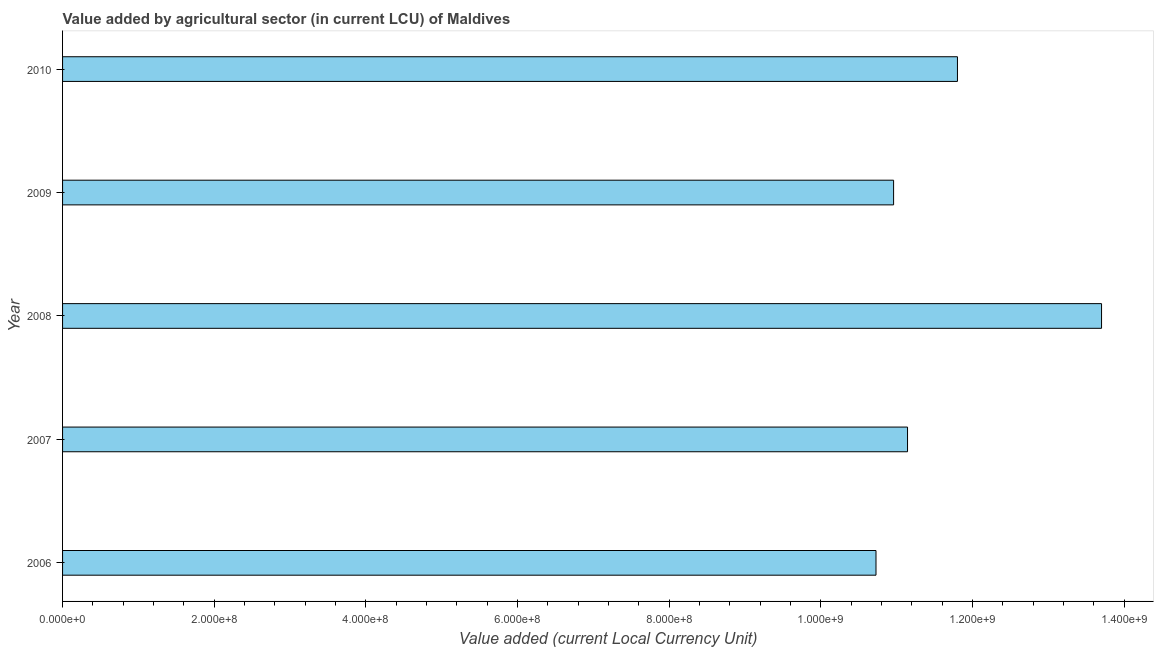Does the graph contain any zero values?
Your answer should be compact. No. What is the title of the graph?
Keep it short and to the point. Value added by agricultural sector (in current LCU) of Maldives. What is the label or title of the X-axis?
Make the answer very short. Value added (current Local Currency Unit). What is the value added by agriculture sector in 2006?
Make the answer very short. 1.07e+09. Across all years, what is the maximum value added by agriculture sector?
Provide a succinct answer. 1.37e+09. Across all years, what is the minimum value added by agriculture sector?
Offer a terse response. 1.07e+09. In which year was the value added by agriculture sector minimum?
Ensure brevity in your answer.  2006. What is the sum of the value added by agriculture sector?
Your response must be concise. 5.83e+09. What is the difference between the value added by agriculture sector in 2007 and 2009?
Make the answer very short. 1.84e+07. What is the average value added by agriculture sector per year?
Make the answer very short. 1.17e+09. What is the median value added by agriculture sector?
Offer a very short reply. 1.11e+09. Do a majority of the years between 2008 and 2007 (inclusive) have value added by agriculture sector greater than 800000000 LCU?
Offer a terse response. No. Is the value added by agriculture sector in 2009 less than that in 2010?
Ensure brevity in your answer.  Yes. Is the difference between the value added by agriculture sector in 2009 and 2010 greater than the difference between any two years?
Provide a short and direct response. No. What is the difference between the highest and the second highest value added by agriculture sector?
Your answer should be compact. 1.90e+08. Is the sum of the value added by agriculture sector in 2008 and 2010 greater than the maximum value added by agriculture sector across all years?
Offer a very short reply. Yes. What is the difference between the highest and the lowest value added by agriculture sector?
Give a very brief answer. 2.97e+08. In how many years, is the value added by agriculture sector greater than the average value added by agriculture sector taken over all years?
Provide a short and direct response. 2. Are all the bars in the graph horizontal?
Offer a very short reply. Yes. How many years are there in the graph?
Your response must be concise. 5. Are the values on the major ticks of X-axis written in scientific E-notation?
Provide a short and direct response. Yes. What is the Value added (current Local Currency Unit) in 2006?
Keep it short and to the point. 1.07e+09. What is the Value added (current Local Currency Unit) in 2007?
Provide a succinct answer. 1.11e+09. What is the Value added (current Local Currency Unit) in 2008?
Provide a succinct answer. 1.37e+09. What is the Value added (current Local Currency Unit) of 2009?
Your answer should be compact. 1.10e+09. What is the Value added (current Local Currency Unit) of 2010?
Offer a terse response. 1.18e+09. What is the difference between the Value added (current Local Currency Unit) in 2006 and 2007?
Provide a succinct answer. -4.16e+07. What is the difference between the Value added (current Local Currency Unit) in 2006 and 2008?
Your answer should be very brief. -2.97e+08. What is the difference between the Value added (current Local Currency Unit) in 2006 and 2009?
Provide a succinct answer. -2.32e+07. What is the difference between the Value added (current Local Currency Unit) in 2006 and 2010?
Your answer should be compact. -1.07e+08. What is the difference between the Value added (current Local Currency Unit) in 2007 and 2008?
Ensure brevity in your answer.  -2.56e+08. What is the difference between the Value added (current Local Currency Unit) in 2007 and 2009?
Provide a short and direct response. 1.84e+07. What is the difference between the Value added (current Local Currency Unit) in 2007 and 2010?
Provide a succinct answer. -6.58e+07. What is the difference between the Value added (current Local Currency Unit) in 2008 and 2009?
Make the answer very short. 2.74e+08. What is the difference between the Value added (current Local Currency Unit) in 2008 and 2010?
Give a very brief answer. 1.90e+08. What is the difference between the Value added (current Local Currency Unit) in 2009 and 2010?
Your response must be concise. -8.42e+07. What is the ratio of the Value added (current Local Currency Unit) in 2006 to that in 2008?
Provide a succinct answer. 0.78. What is the ratio of the Value added (current Local Currency Unit) in 2006 to that in 2009?
Make the answer very short. 0.98. What is the ratio of the Value added (current Local Currency Unit) in 2006 to that in 2010?
Ensure brevity in your answer.  0.91. What is the ratio of the Value added (current Local Currency Unit) in 2007 to that in 2008?
Keep it short and to the point. 0.81. What is the ratio of the Value added (current Local Currency Unit) in 2007 to that in 2009?
Your answer should be compact. 1.02. What is the ratio of the Value added (current Local Currency Unit) in 2007 to that in 2010?
Offer a terse response. 0.94. What is the ratio of the Value added (current Local Currency Unit) in 2008 to that in 2010?
Your answer should be very brief. 1.16. What is the ratio of the Value added (current Local Currency Unit) in 2009 to that in 2010?
Provide a succinct answer. 0.93. 